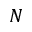<formula> <loc_0><loc_0><loc_500><loc_500>N</formula> 